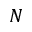<formula> <loc_0><loc_0><loc_500><loc_500>N</formula> 